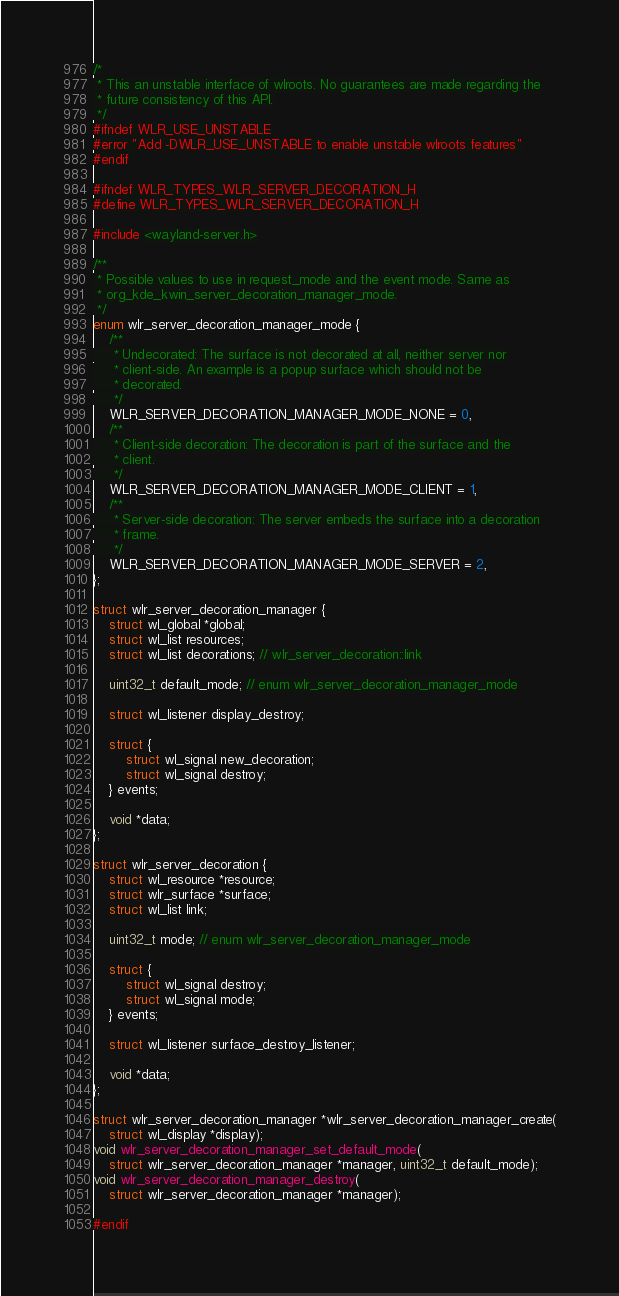<code> <loc_0><loc_0><loc_500><loc_500><_C_>/*
 * This an unstable interface of wlroots. No guarantees are made regarding the
 * future consistency of this API.
 */
#ifndef WLR_USE_UNSTABLE
#error "Add -DWLR_USE_UNSTABLE to enable unstable wlroots features"
#endif

#ifndef WLR_TYPES_WLR_SERVER_DECORATION_H
#define WLR_TYPES_WLR_SERVER_DECORATION_H

#include <wayland-server.h>

/**
 * Possible values to use in request_mode and the event mode. Same as
 * org_kde_kwin_server_decoration_manager_mode.
 */
enum wlr_server_decoration_manager_mode {
	/**
	 * Undecorated: The surface is not decorated at all, neither server nor
	 * client-side. An example is a popup surface which should not be
	 * decorated.
	 */
	WLR_SERVER_DECORATION_MANAGER_MODE_NONE = 0,
	/**
	 * Client-side decoration: The decoration is part of the surface and the
	 * client.
	 */
	WLR_SERVER_DECORATION_MANAGER_MODE_CLIENT = 1,
	/**
	 * Server-side decoration: The server embeds the surface into a decoration
	 * frame.
	 */
	WLR_SERVER_DECORATION_MANAGER_MODE_SERVER = 2,
};

struct wlr_server_decoration_manager {
	struct wl_global *global;
	struct wl_list resources;
	struct wl_list decorations; // wlr_server_decoration::link

	uint32_t default_mode; // enum wlr_server_decoration_manager_mode

	struct wl_listener display_destroy;

	struct {
		struct wl_signal new_decoration;
		struct wl_signal destroy;
	} events;

	void *data;
};

struct wlr_server_decoration {
	struct wl_resource *resource;
	struct wlr_surface *surface;
	struct wl_list link;

	uint32_t mode; // enum wlr_server_decoration_manager_mode

	struct {
		struct wl_signal destroy;
		struct wl_signal mode;
	} events;

	struct wl_listener surface_destroy_listener;

	void *data;
};

struct wlr_server_decoration_manager *wlr_server_decoration_manager_create(
	struct wl_display *display);
void wlr_server_decoration_manager_set_default_mode(
	struct wlr_server_decoration_manager *manager, uint32_t default_mode);
void wlr_server_decoration_manager_destroy(
	struct wlr_server_decoration_manager *manager);

#endif
</code> 